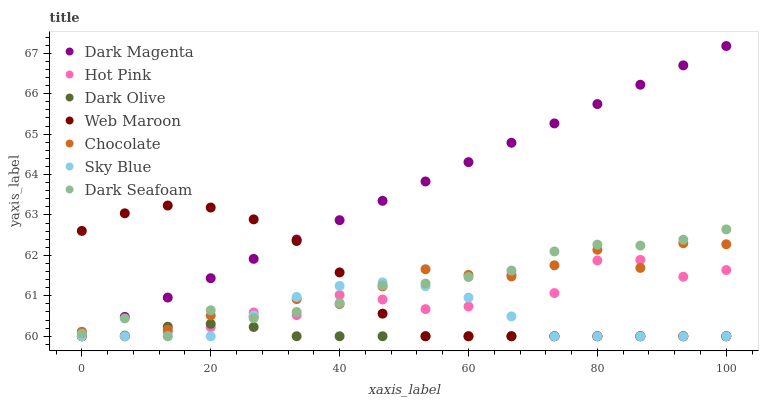Does Dark Olive have the minimum area under the curve?
Answer yes or no. Yes. Does Dark Magenta have the maximum area under the curve?
Answer yes or no. Yes. Does Dark Magenta have the minimum area under the curve?
Answer yes or no. No. Does Dark Olive have the maximum area under the curve?
Answer yes or no. No. Is Dark Magenta the smoothest?
Answer yes or no. Yes. Is Hot Pink the roughest?
Answer yes or no. Yes. Is Dark Olive the smoothest?
Answer yes or no. No. Is Dark Olive the roughest?
Answer yes or no. No. Does Hot Pink have the lowest value?
Answer yes or no. Yes. Does Dark Magenta have the highest value?
Answer yes or no. Yes. Does Dark Olive have the highest value?
Answer yes or no. No. Does Hot Pink intersect Dark Olive?
Answer yes or no. Yes. Is Hot Pink less than Dark Olive?
Answer yes or no. No. Is Hot Pink greater than Dark Olive?
Answer yes or no. No. 